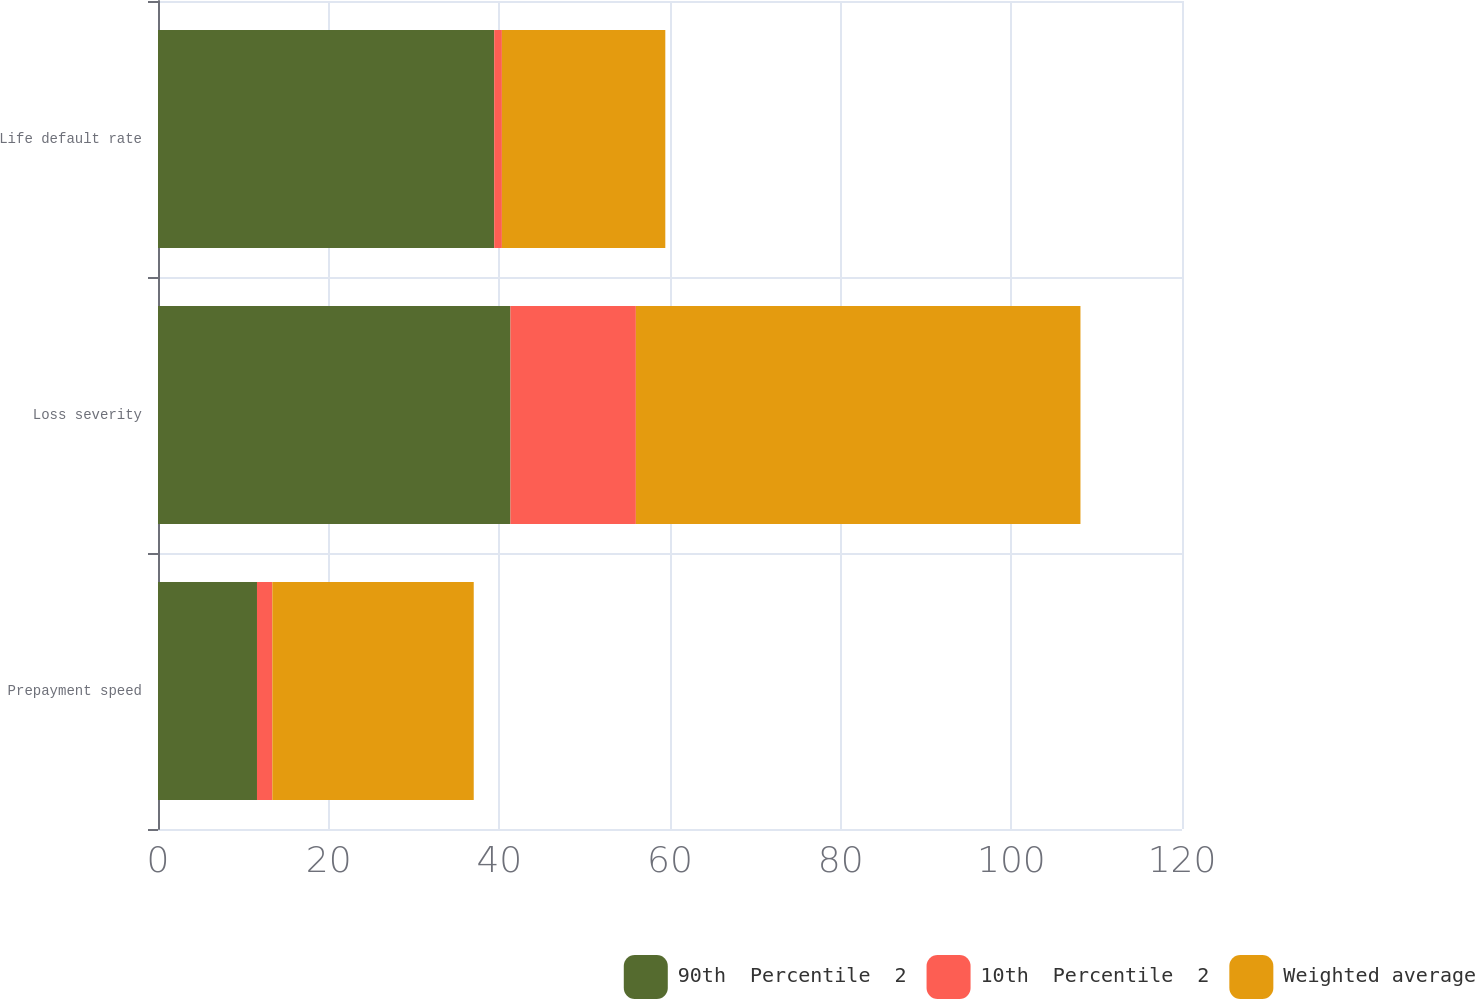<chart> <loc_0><loc_0><loc_500><loc_500><stacked_bar_chart><ecel><fcel>Prepayment speed<fcel>Loss severity<fcel>Life default rate<nl><fcel>90th  Percentile  2<fcel>11.6<fcel>41.3<fcel>39.4<nl><fcel>10th  Percentile  2<fcel>1.8<fcel>14.7<fcel>0.9<nl><fcel>Weighted average<fcel>23.6<fcel>52.1<fcel>19.15<nl></chart> 